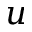Convert formula to latex. <formula><loc_0><loc_0><loc_500><loc_500>u</formula> 